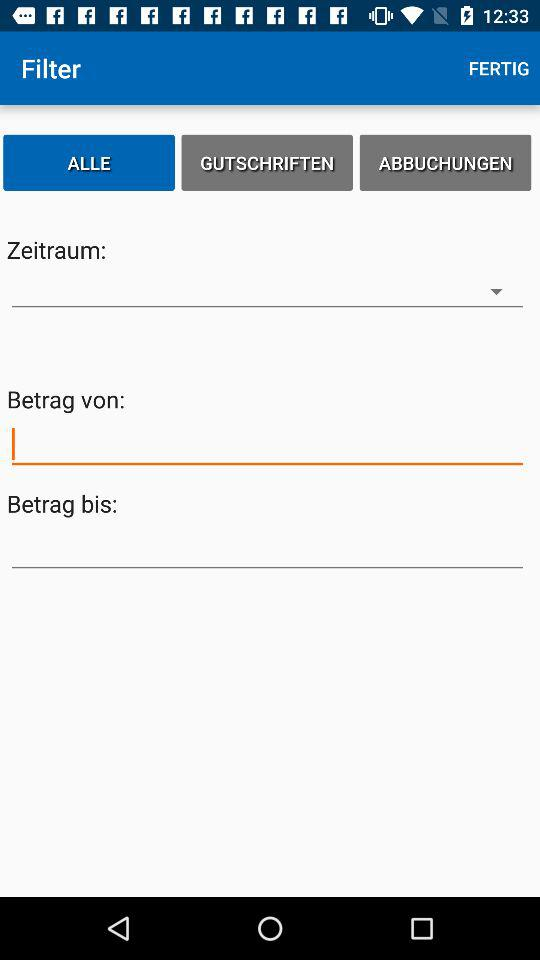Which tab am I on? You are on the "ALLE" tab. 